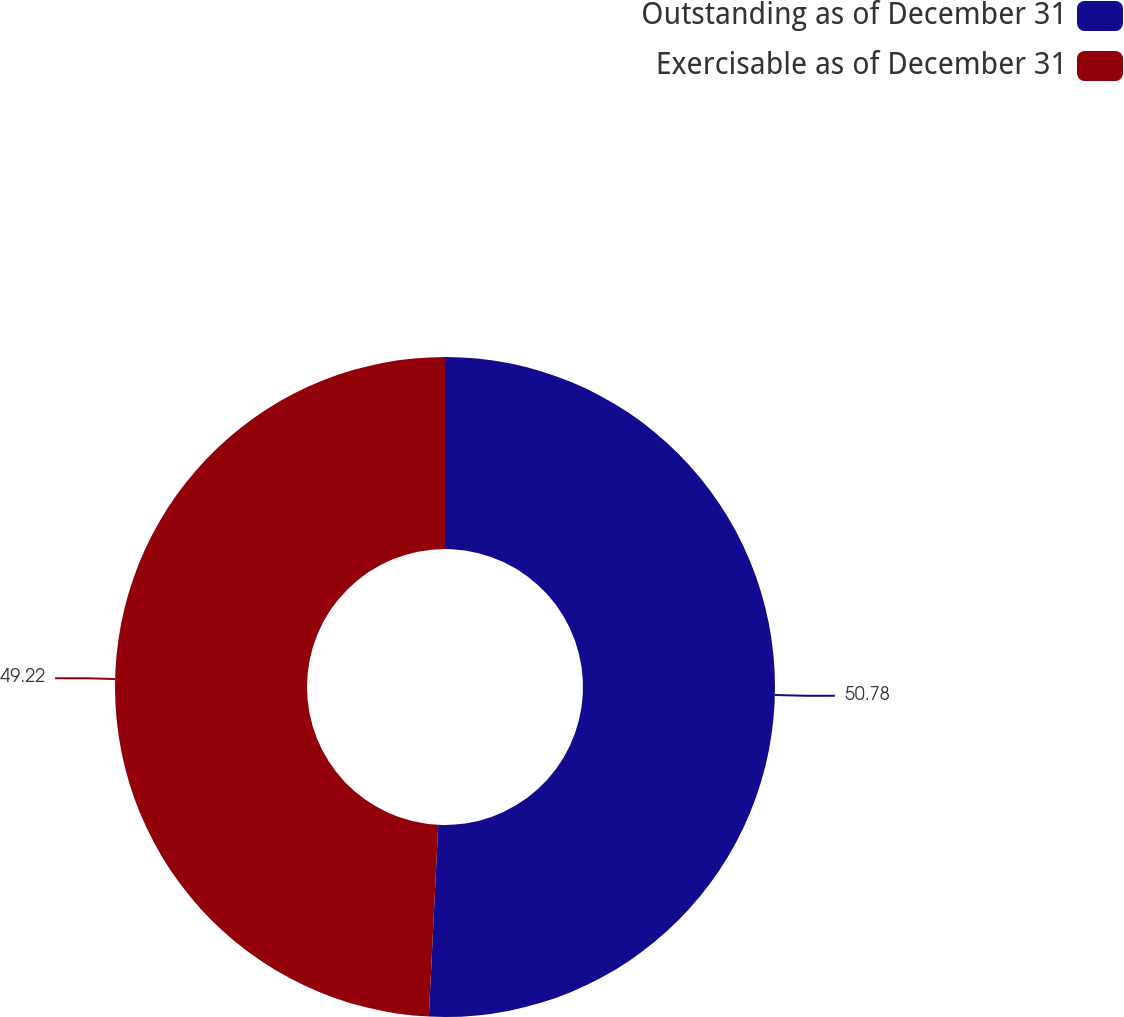Convert chart. <chart><loc_0><loc_0><loc_500><loc_500><pie_chart><fcel>Outstanding as of December 31<fcel>Exercisable as of December 31<nl><fcel>50.78%<fcel>49.22%<nl></chart> 